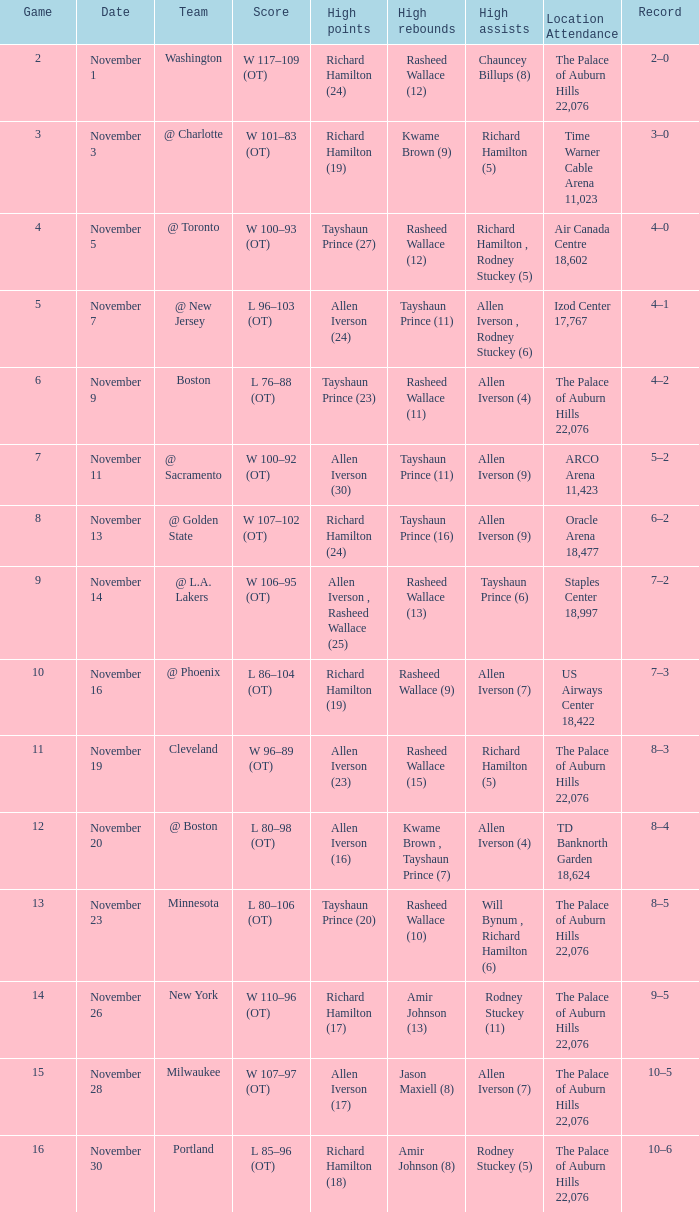What is the location presence, when high points is "allen iverson (23)"? The Palace of Auburn Hills 22,076. 